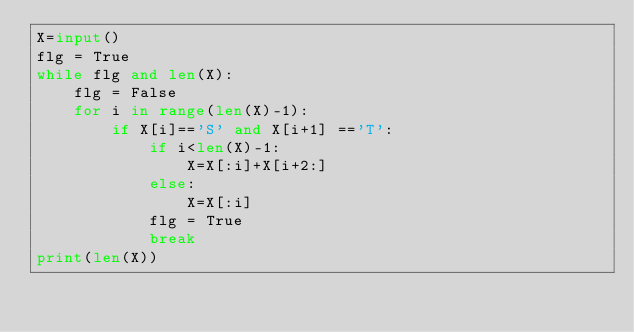Convert code to text. <code><loc_0><loc_0><loc_500><loc_500><_Python_>X=input()
flg = True
while flg and len(X):
    flg = False
    for i in range(len(X)-1):
        if X[i]=='S' and X[i+1] =='T':
            if i<len(X)-1:
                X=X[:i]+X[i+2:]
            else:
                X=X[:i]
            flg = True
            break
print(len(X))</code> 